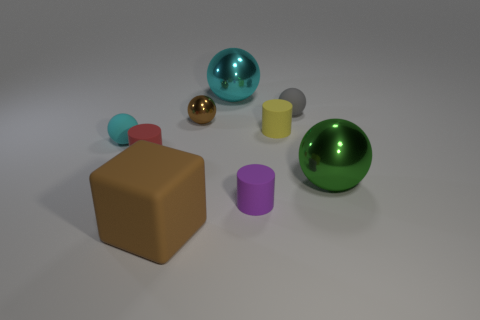Can you speculate on the purpose of this 3D render? This 3D rendering could serve multiple purposes. It might be an artist's exploration of shape, color, and texture. Alternatively, it could be a sample scene created to demonstrate rendering techniques, lighting effects, and material properties in a 3D modeling software. The precise and clean presentation indicates a likelihood of educational or demonstrative intent. 